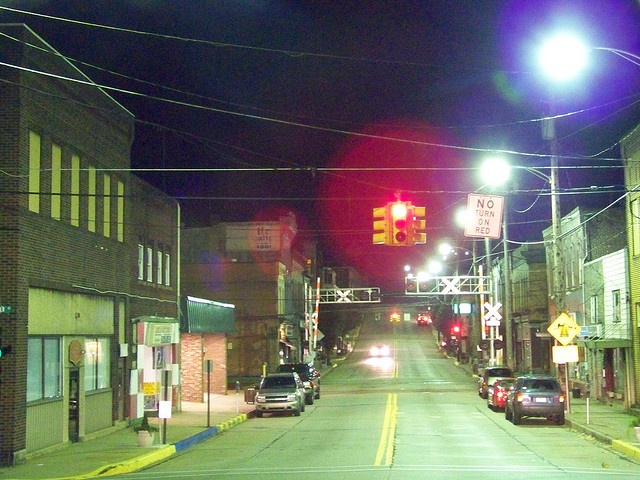Describe the objects in this image and their specific colors. I can see car in darkgreen, gray, darkgray, and black tones, car in darkgreen, gray, black, and darkgray tones, traffic light in darkgreen, orange, and brown tones, car in darkgreen, black, gray, and olive tones, and truck in darkgreen, black, gray, and olive tones in this image. 